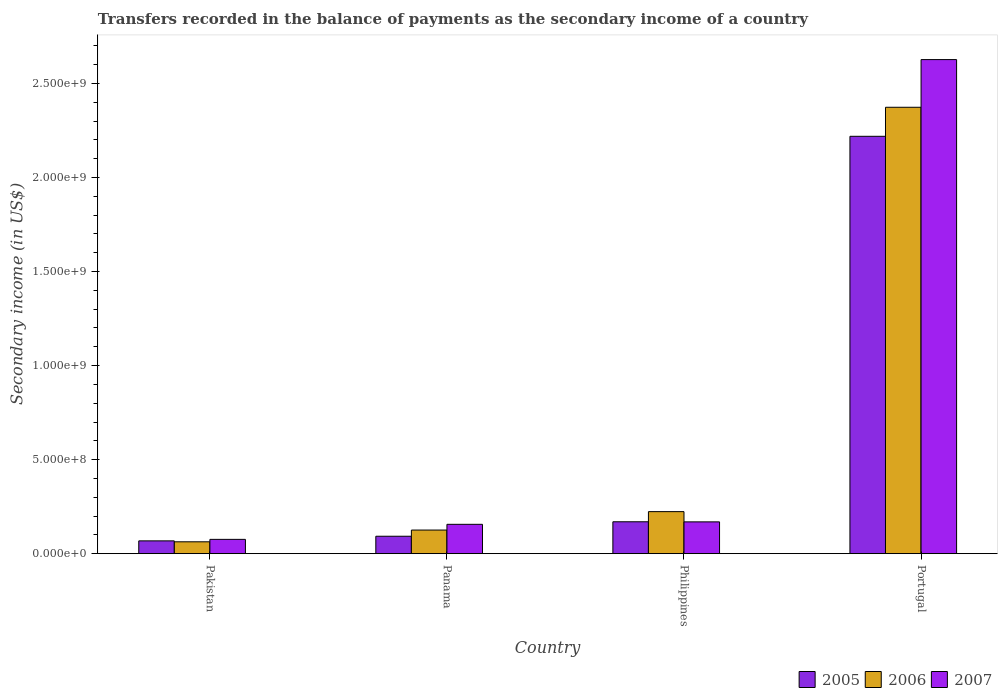How many different coloured bars are there?
Offer a very short reply. 3. How many groups of bars are there?
Your answer should be very brief. 4. Are the number of bars per tick equal to the number of legend labels?
Provide a short and direct response. Yes. Are the number of bars on each tick of the X-axis equal?
Provide a succinct answer. Yes. How many bars are there on the 3rd tick from the left?
Offer a terse response. 3. How many bars are there on the 1st tick from the right?
Ensure brevity in your answer.  3. What is the label of the 1st group of bars from the left?
Provide a short and direct response. Pakistan. What is the secondary income of in 2006 in Panama?
Keep it short and to the point. 1.26e+08. Across all countries, what is the maximum secondary income of in 2006?
Your response must be concise. 2.37e+09. Across all countries, what is the minimum secondary income of in 2005?
Provide a succinct answer. 6.80e+07. In which country was the secondary income of in 2006 maximum?
Keep it short and to the point. Portugal. What is the total secondary income of in 2006 in the graph?
Keep it short and to the point. 2.79e+09. What is the difference between the secondary income of in 2006 in Pakistan and that in Panama?
Your response must be concise. -6.25e+07. What is the difference between the secondary income of in 2006 in Pakistan and the secondary income of in 2005 in Panama?
Give a very brief answer. -2.96e+07. What is the average secondary income of in 2007 per country?
Provide a short and direct response. 7.57e+08. What is the difference between the secondary income of of/in 2006 and secondary income of of/in 2007 in Pakistan?
Offer a terse response. -1.30e+07. What is the ratio of the secondary income of in 2007 in Panama to that in Philippines?
Make the answer very short. 0.92. Is the secondary income of in 2007 in Philippines less than that in Portugal?
Your answer should be very brief. Yes. What is the difference between the highest and the second highest secondary income of in 2006?
Make the answer very short. -2.25e+09. What is the difference between the highest and the lowest secondary income of in 2007?
Your answer should be very brief. 2.55e+09. Is the sum of the secondary income of in 2006 in Pakistan and Panama greater than the maximum secondary income of in 2007 across all countries?
Provide a succinct answer. No. What does the 1st bar from the left in Portugal represents?
Provide a succinct answer. 2005. What does the 3rd bar from the right in Panama represents?
Your answer should be very brief. 2005. Is it the case that in every country, the sum of the secondary income of in 2006 and secondary income of in 2005 is greater than the secondary income of in 2007?
Make the answer very short. Yes. Are the values on the major ticks of Y-axis written in scientific E-notation?
Offer a terse response. Yes. Does the graph contain any zero values?
Offer a terse response. No. Does the graph contain grids?
Keep it short and to the point. No. What is the title of the graph?
Offer a terse response. Transfers recorded in the balance of payments as the secondary income of a country. What is the label or title of the X-axis?
Give a very brief answer. Country. What is the label or title of the Y-axis?
Your answer should be compact. Secondary income (in US$). What is the Secondary income (in US$) of 2005 in Pakistan?
Keep it short and to the point. 6.80e+07. What is the Secondary income (in US$) in 2006 in Pakistan?
Make the answer very short. 6.30e+07. What is the Secondary income (in US$) of 2007 in Pakistan?
Your answer should be compact. 7.60e+07. What is the Secondary income (in US$) of 2005 in Panama?
Give a very brief answer. 9.26e+07. What is the Secondary income (in US$) in 2006 in Panama?
Make the answer very short. 1.26e+08. What is the Secondary income (in US$) of 2007 in Panama?
Make the answer very short. 1.56e+08. What is the Secondary income (in US$) of 2005 in Philippines?
Offer a very short reply. 1.69e+08. What is the Secondary income (in US$) in 2006 in Philippines?
Offer a terse response. 2.23e+08. What is the Secondary income (in US$) in 2007 in Philippines?
Make the answer very short. 1.69e+08. What is the Secondary income (in US$) in 2005 in Portugal?
Give a very brief answer. 2.22e+09. What is the Secondary income (in US$) in 2006 in Portugal?
Give a very brief answer. 2.37e+09. What is the Secondary income (in US$) in 2007 in Portugal?
Give a very brief answer. 2.63e+09. Across all countries, what is the maximum Secondary income (in US$) of 2005?
Give a very brief answer. 2.22e+09. Across all countries, what is the maximum Secondary income (in US$) of 2006?
Your answer should be compact. 2.37e+09. Across all countries, what is the maximum Secondary income (in US$) in 2007?
Ensure brevity in your answer.  2.63e+09. Across all countries, what is the minimum Secondary income (in US$) of 2005?
Your response must be concise. 6.80e+07. Across all countries, what is the minimum Secondary income (in US$) of 2006?
Your answer should be very brief. 6.30e+07. Across all countries, what is the minimum Secondary income (in US$) in 2007?
Keep it short and to the point. 7.60e+07. What is the total Secondary income (in US$) in 2005 in the graph?
Give a very brief answer. 2.55e+09. What is the total Secondary income (in US$) in 2006 in the graph?
Provide a short and direct response. 2.79e+09. What is the total Secondary income (in US$) of 2007 in the graph?
Provide a succinct answer. 3.03e+09. What is the difference between the Secondary income (in US$) of 2005 in Pakistan and that in Panama?
Provide a short and direct response. -2.46e+07. What is the difference between the Secondary income (in US$) of 2006 in Pakistan and that in Panama?
Offer a terse response. -6.25e+07. What is the difference between the Secondary income (in US$) of 2007 in Pakistan and that in Panama?
Provide a short and direct response. -8.00e+07. What is the difference between the Secondary income (in US$) of 2005 in Pakistan and that in Philippines?
Your response must be concise. -1.01e+08. What is the difference between the Secondary income (in US$) in 2006 in Pakistan and that in Philippines?
Offer a very short reply. -1.60e+08. What is the difference between the Secondary income (in US$) of 2007 in Pakistan and that in Philippines?
Ensure brevity in your answer.  -9.30e+07. What is the difference between the Secondary income (in US$) in 2005 in Pakistan and that in Portugal?
Make the answer very short. -2.15e+09. What is the difference between the Secondary income (in US$) of 2006 in Pakistan and that in Portugal?
Keep it short and to the point. -2.31e+09. What is the difference between the Secondary income (in US$) of 2007 in Pakistan and that in Portugal?
Your response must be concise. -2.55e+09. What is the difference between the Secondary income (in US$) in 2005 in Panama and that in Philippines?
Your answer should be compact. -7.69e+07. What is the difference between the Secondary income (in US$) of 2006 in Panama and that in Philippines?
Ensure brevity in your answer.  -9.80e+07. What is the difference between the Secondary income (in US$) in 2007 in Panama and that in Philippines?
Provide a succinct answer. -1.30e+07. What is the difference between the Secondary income (in US$) of 2005 in Panama and that in Portugal?
Offer a very short reply. -2.13e+09. What is the difference between the Secondary income (in US$) in 2006 in Panama and that in Portugal?
Provide a succinct answer. -2.25e+09. What is the difference between the Secondary income (in US$) of 2007 in Panama and that in Portugal?
Your response must be concise. -2.47e+09. What is the difference between the Secondary income (in US$) in 2005 in Philippines and that in Portugal?
Keep it short and to the point. -2.05e+09. What is the difference between the Secondary income (in US$) of 2006 in Philippines and that in Portugal?
Offer a terse response. -2.15e+09. What is the difference between the Secondary income (in US$) of 2007 in Philippines and that in Portugal?
Your answer should be very brief. -2.46e+09. What is the difference between the Secondary income (in US$) in 2005 in Pakistan and the Secondary income (in US$) in 2006 in Panama?
Your answer should be very brief. -5.75e+07. What is the difference between the Secondary income (in US$) of 2005 in Pakistan and the Secondary income (in US$) of 2007 in Panama?
Offer a very short reply. -8.80e+07. What is the difference between the Secondary income (in US$) of 2006 in Pakistan and the Secondary income (in US$) of 2007 in Panama?
Your answer should be compact. -9.30e+07. What is the difference between the Secondary income (in US$) of 2005 in Pakistan and the Secondary income (in US$) of 2006 in Philippines?
Keep it short and to the point. -1.55e+08. What is the difference between the Secondary income (in US$) in 2005 in Pakistan and the Secondary income (in US$) in 2007 in Philippines?
Provide a succinct answer. -1.01e+08. What is the difference between the Secondary income (in US$) of 2006 in Pakistan and the Secondary income (in US$) of 2007 in Philippines?
Offer a very short reply. -1.06e+08. What is the difference between the Secondary income (in US$) in 2005 in Pakistan and the Secondary income (in US$) in 2006 in Portugal?
Give a very brief answer. -2.31e+09. What is the difference between the Secondary income (in US$) in 2005 in Pakistan and the Secondary income (in US$) in 2007 in Portugal?
Your answer should be very brief. -2.56e+09. What is the difference between the Secondary income (in US$) of 2006 in Pakistan and the Secondary income (in US$) of 2007 in Portugal?
Your answer should be compact. -2.56e+09. What is the difference between the Secondary income (in US$) in 2005 in Panama and the Secondary income (in US$) in 2006 in Philippines?
Your answer should be very brief. -1.31e+08. What is the difference between the Secondary income (in US$) in 2005 in Panama and the Secondary income (in US$) in 2007 in Philippines?
Provide a short and direct response. -7.64e+07. What is the difference between the Secondary income (in US$) in 2006 in Panama and the Secondary income (in US$) in 2007 in Philippines?
Your answer should be very brief. -4.35e+07. What is the difference between the Secondary income (in US$) of 2005 in Panama and the Secondary income (in US$) of 2006 in Portugal?
Provide a short and direct response. -2.28e+09. What is the difference between the Secondary income (in US$) of 2005 in Panama and the Secondary income (in US$) of 2007 in Portugal?
Provide a succinct answer. -2.53e+09. What is the difference between the Secondary income (in US$) of 2006 in Panama and the Secondary income (in US$) of 2007 in Portugal?
Provide a short and direct response. -2.50e+09. What is the difference between the Secondary income (in US$) of 2005 in Philippines and the Secondary income (in US$) of 2006 in Portugal?
Your answer should be compact. -2.20e+09. What is the difference between the Secondary income (in US$) in 2005 in Philippines and the Secondary income (in US$) in 2007 in Portugal?
Your response must be concise. -2.46e+09. What is the difference between the Secondary income (in US$) in 2006 in Philippines and the Secondary income (in US$) in 2007 in Portugal?
Ensure brevity in your answer.  -2.40e+09. What is the average Secondary income (in US$) of 2005 per country?
Provide a succinct answer. 6.37e+08. What is the average Secondary income (in US$) of 2006 per country?
Your answer should be compact. 6.96e+08. What is the average Secondary income (in US$) of 2007 per country?
Offer a terse response. 7.57e+08. What is the difference between the Secondary income (in US$) of 2005 and Secondary income (in US$) of 2007 in Pakistan?
Your response must be concise. -8.00e+06. What is the difference between the Secondary income (in US$) in 2006 and Secondary income (in US$) in 2007 in Pakistan?
Ensure brevity in your answer.  -1.30e+07. What is the difference between the Secondary income (in US$) of 2005 and Secondary income (in US$) of 2006 in Panama?
Ensure brevity in your answer.  -3.29e+07. What is the difference between the Secondary income (in US$) of 2005 and Secondary income (in US$) of 2007 in Panama?
Your answer should be compact. -6.34e+07. What is the difference between the Secondary income (in US$) in 2006 and Secondary income (in US$) in 2007 in Panama?
Give a very brief answer. -3.05e+07. What is the difference between the Secondary income (in US$) of 2005 and Secondary income (in US$) of 2006 in Philippines?
Ensure brevity in your answer.  -5.40e+07. What is the difference between the Secondary income (in US$) in 2005 and Secondary income (in US$) in 2007 in Philippines?
Your answer should be compact. 4.85e+05. What is the difference between the Secondary income (in US$) of 2006 and Secondary income (in US$) of 2007 in Philippines?
Provide a succinct answer. 5.45e+07. What is the difference between the Secondary income (in US$) in 2005 and Secondary income (in US$) in 2006 in Portugal?
Provide a short and direct response. -1.54e+08. What is the difference between the Secondary income (in US$) of 2005 and Secondary income (in US$) of 2007 in Portugal?
Keep it short and to the point. -4.08e+08. What is the difference between the Secondary income (in US$) in 2006 and Secondary income (in US$) in 2007 in Portugal?
Give a very brief answer. -2.54e+08. What is the ratio of the Secondary income (in US$) of 2005 in Pakistan to that in Panama?
Give a very brief answer. 0.73. What is the ratio of the Secondary income (in US$) in 2006 in Pakistan to that in Panama?
Your answer should be compact. 0.5. What is the ratio of the Secondary income (in US$) in 2007 in Pakistan to that in Panama?
Give a very brief answer. 0.49. What is the ratio of the Secondary income (in US$) of 2005 in Pakistan to that in Philippines?
Your answer should be compact. 0.4. What is the ratio of the Secondary income (in US$) in 2006 in Pakistan to that in Philippines?
Ensure brevity in your answer.  0.28. What is the ratio of the Secondary income (in US$) of 2007 in Pakistan to that in Philippines?
Keep it short and to the point. 0.45. What is the ratio of the Secondary income (in US$) in 2005 in Pakistan to that in Portugal?
Your answer should be compact. 0.03. What is the ratio of the Secondary income (in US$) of 2006 in Pakistan to that in Portugal?
Provide a short and direct response. 0.03. What is the ratio of the Secondary income (in US$) of 2007 in Pakistan to that in Portugal?
Give a very brief answer. 0.03. What is the ratio of the Secondary income (in US$) of 2005 in Panama to that in Philippines?
Provide a short and direct response. 0.55. What is the ratio of the Secondary income (in US$) in 2006 in Panama to that in Philippines?
Keep it short and to the point. 0.56. What is the ratio of the Secondary income (in US$) in 2007 in Panama to that in Philippines?
Your response must be concise. 0.92. What is the ratio of the Secondary income (in US$) in 2005 in Panama to that in Portugal?
Keep it short and to the point. 0.04. What is the ratio of the Secondary income (in US$) of 2006 in Panama to that in Portugal?
Provide a succinct answer. 0.05. What is the ratio of the Secondary income (in US$) in 2007 in Panama to that in Portugal?
Make the answer very short. 0.06. What is the ratio of the Secondary income (in US$) of 2005 in Philippines to that in Portugal?
Your response must be concise. 0.08. What is the ratio of the Secondary income (in US$) of 2006 in Philippines to that in Portugal?
Your response must be concise. 0.09. What is the ratio of the Secondary income (in US$) in 2007 in Philippines to that in Portugal?
Keep it short and to the point. 0.06. What is the difference between the highest and the second highest Secondary income (in US$) of 2005?
Make the answer very short. 2.05e+09. What is the difference between the highest and the second highest Secondary income (in US$) of 2006?
Make the answer very short. 2.15e+09. What is the difference between the highest and the second highest Secondary income (in US$) of 2007?
Make the answer very short. 2.46e+09. What is the difference between the highest and the lowest Secondary income (in US$) in 2005?
Your answer should be compact. 2.15e+09. What is the difference between the highest and the lowest Secondary income (in US$) in 2006?
Provide a succinct answer. 2.31e+09. What is the difference between the highest and the lowest Secondary income (in US$) of 2007?
Keep it short and to the point. 2.55e+09. 